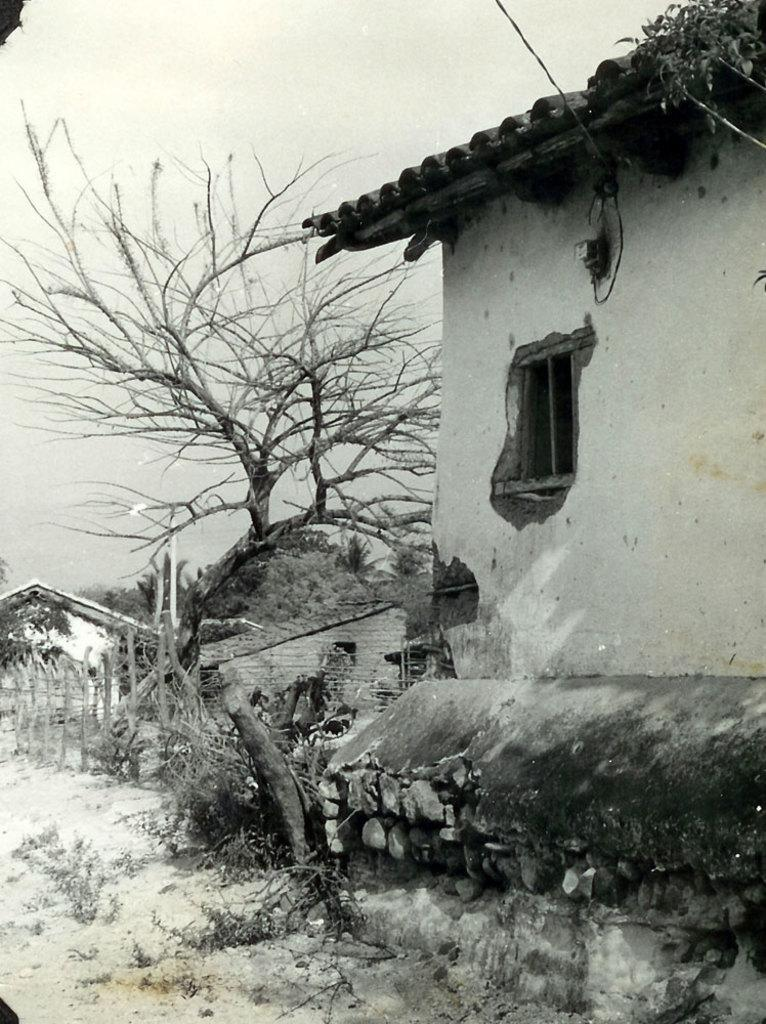What is the color scheme of the image? The image is black and white. What type of structures can be seen in the image? There are houses in the image. What type of vegetation is present in the image? There are trees and plants in the image. What type of barrier can be seen in the image? There is a fence in the image. What parts of the environment are visible in the image? The sky and the ground are visible in the image. What type of education is being taught in the image? There is no indication of education or teaching in the image; it primarily features houses, trees, plants, a fence, and the sky and ground. Can you see a chessboard in the image? There is no chessboard present in the image. 